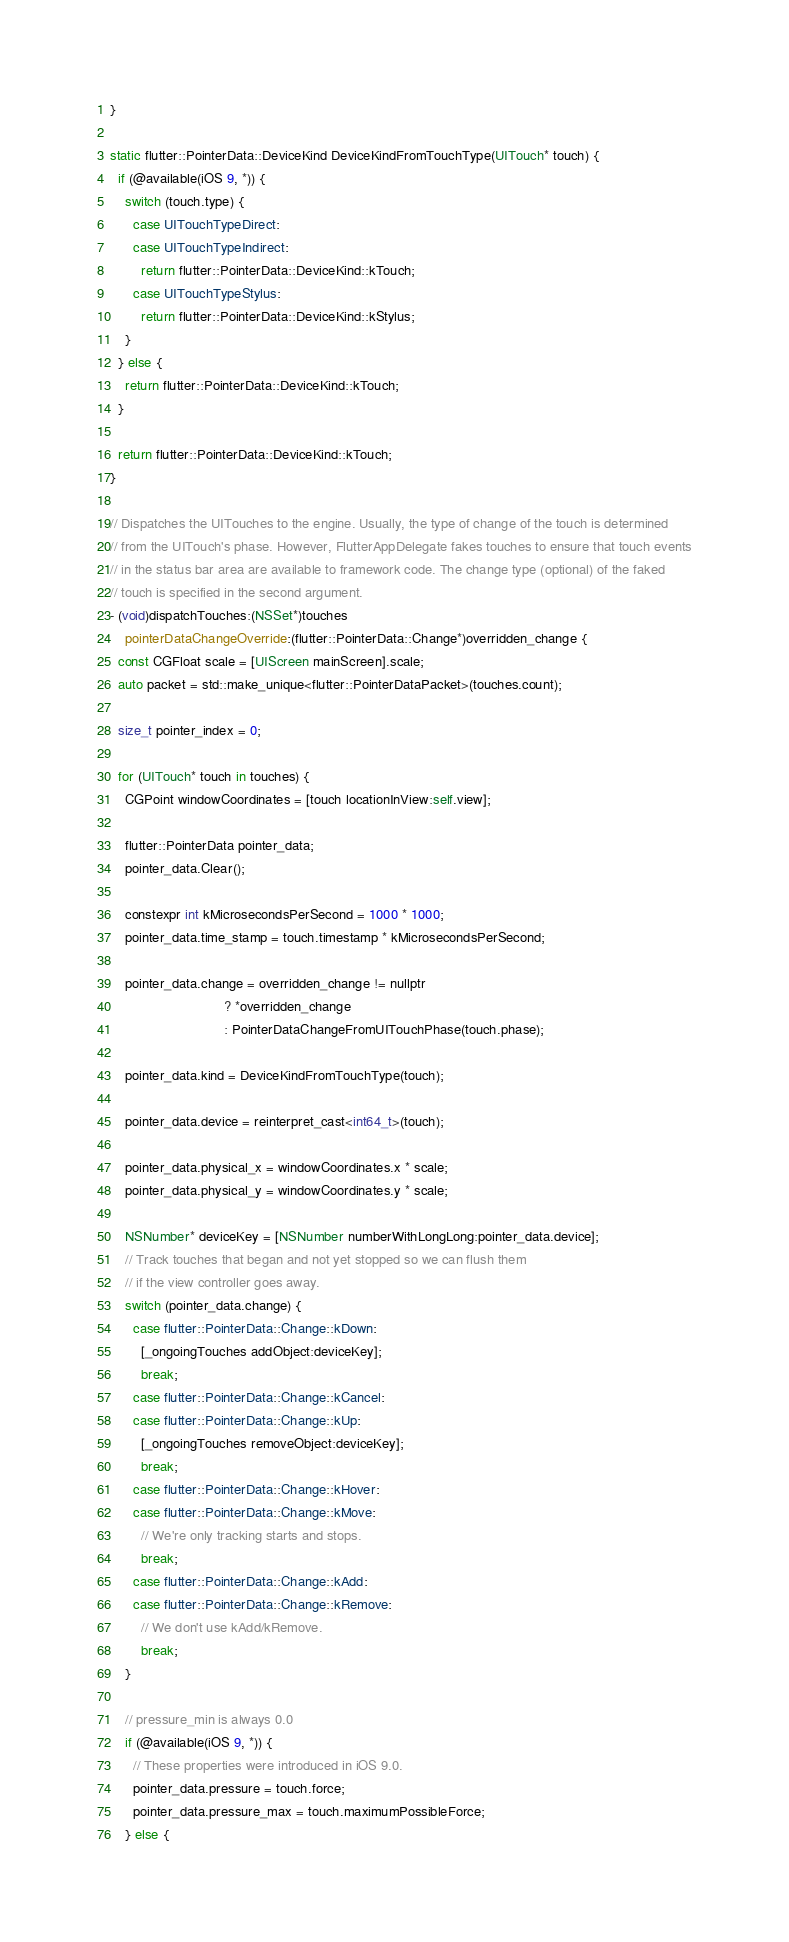<code> <loc_0><loc_0><loc_500><loc_500><_ObjectiveC_>}

static flutter::PointerData::DeviceKind DeviceKindFromTouchType(UITouch* touch) {
  if (@available(iOS 9, *)) {
    switch (touch.type) {
      case UITouchTypeDirect:
      case UITouchTypeIndirect:
        return flutter::PointerData::DeviceKind::kTouch;
      case UITouchTypeStylus:
        return flutter::PointerData::DeviceKind::kStylus;
    }
  } else {
    return flutter::PointerData::DeviceKind::kTouch;
  }

  return flutter::PointerData::DeviceKind::kTouch;
}

// Dispatches the UITouches to the engine. Usually, the type of change of the touch is determined
// from the UITouch's phase. However, FlutterAppDelegate fakes touches to ensure that touch events
// in the status bar area are available to framework code. The change type (optional) of the faked
// touch is specified in the second argument.
- (void)dispatchTouches:(NSSet*)touches
    pointerDataChangeOverride:(flutter::PointerData::Change*)overridden_change {
  const CGFloat scale = [UIScreen mainScreen].scale;
  auto packet = std::make_unique<flutter::PointerDataPacket>(touches.count);

  size_t pointer_index = 0;

  for (UITouch* touch in touches) {
    CGPoint windowCoordinates = [touch locationInView:self.view];

    flutter::PointerData pointer_data;
    pointer_data.Clear();

    constexpr int kMicrosecondsPerSecond = 1000 * 1000;
    pointer_data.time_stamp = touch.timestamp * kMicrosecondsPerSecond;

    pointer_data.change = overridden_change != nullptr
                              ? *overridden_change
                              : PointerDataChangeFromUITouchPhase(touch.phase);

    pointer_data.kind = DeviceKindFromTouchType(touch);

    pointer_data.device = reinterpret_cast<int64_t>(touch);

    pointer_data.physical_x = windowCoordinates.x * scale;
    pointer_data.physical_y = windowCoordinates.y * scale;

    NSNumber* deviceKey = [NSNumber numberWithLongLong:pointer_data.device];
    // Track touches that began and not yet stopped so we can flush them
    // if the view controller goes away.
    switch (pointer_data.change) {
      case flutter::PointerData::Change::kDown:
        [_ongoingTouches addObject:deviceKey];
        break;
      case flutter::PointerData::Change::kCancel:
      case flutter::PointerData::Change::kUp:
        [_ongoingTouches removeObject:deviceKey];
        break;
      case flutter::PointerData::Change::kHover:
      case flutter::PointerData::Change::kMove:
        // We're only tracking starts and stops.
        break;
      case flutter::PointerData::Change::kAdd:
      case flutter::PointerData::Change::kRemove:
        // We don't use kAdd/kRemove.
        break;
    }

    // pressure_min is always 0.0
    if (@available(iOS 9, *)) {
      // These properties were introduced in iOS 9.0.
      pointer_data.pressure = touch.force;
      pointer_data.pressure_max = touch.maximumPossibleForce;
    } else {</code> 